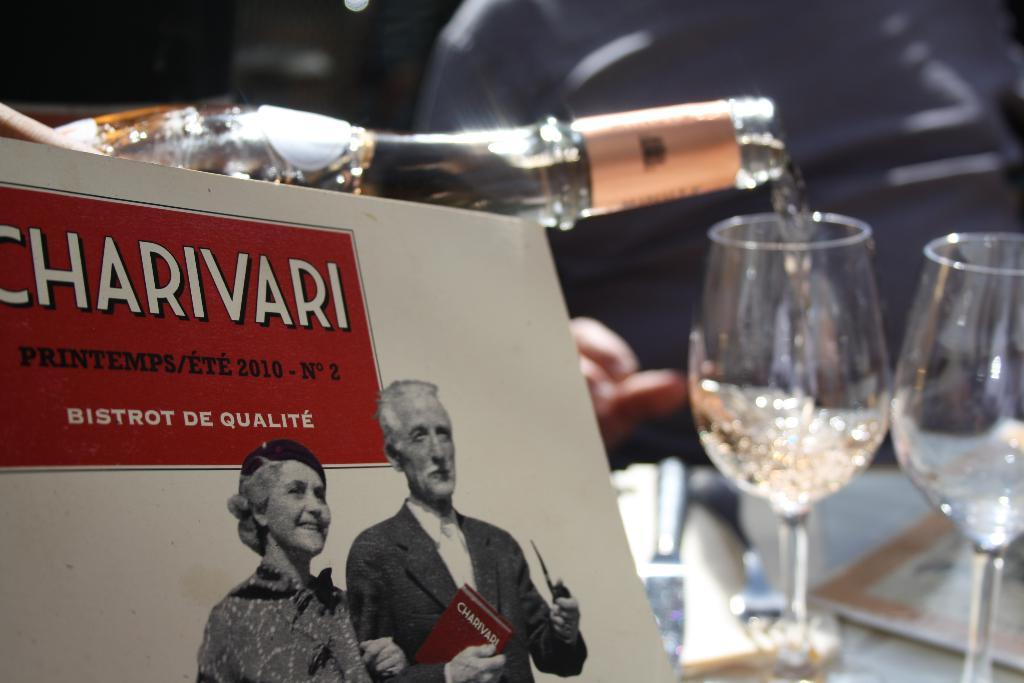Who are the people in the image? There is a woman and a man in the image. What is the medium of the image? The woman and man are depicted on a paper. What objects are present in the image besides the people? There is a bottle and two glasses in the image. What type of pizzas are being served in the image? There are no pizzas present in the image. What is the opinion of the woman regarding the man in the image? The image does not convey any opinions or emotions of the woman or the man. 